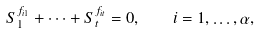Convert formula to latex. <formula><loc_0><loc_0><loc_500><loc_500>S _ { 1 } ^ { f _ { i 1 } } + \dots + S _ { t } ^ { f _ { i t } } = 0 , \quad i = 1 , \dots , \alpha ,</formula> 